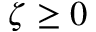<formula> <loc_0><loc_0><loc_500><loc_500>\zeta \geq 0</formula> 